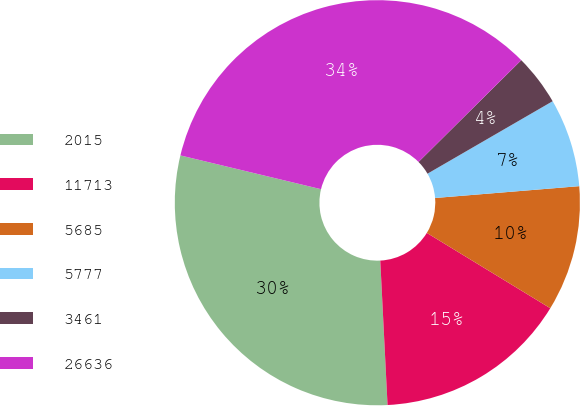Convert chart to OTSL. <chart><loc_0><loc_0><loc_500><loc_500><pie_chart><fcel>2015<fcel>11713<fcel>5685<fcel>5777<fcel>3461<fcel>26636<nl><fcel>29.55%<fcel>15.48%<fcel>10.02%<fcel>7.05%<fcel>4.07%<fcel>33.82%<nl></chart> 